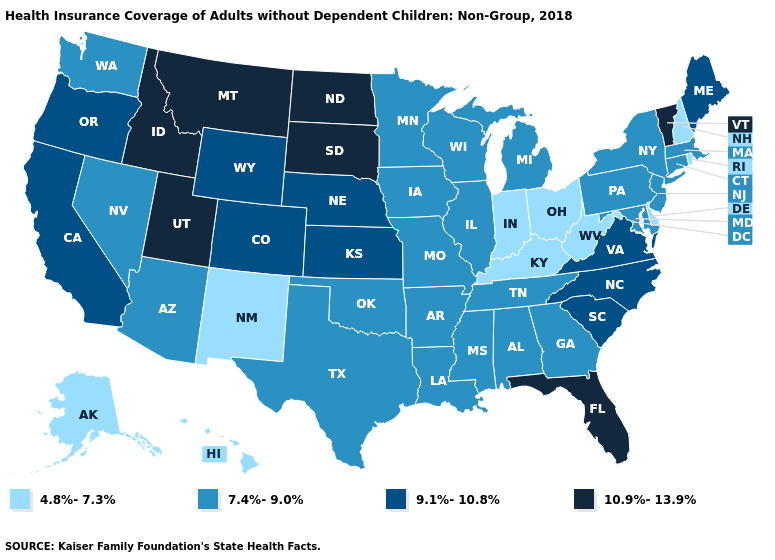What is the value of New Hampshire?
Short answer required. 4.8%-7.3%. Does the first symbol in the legend represent the smallest category?
Short answer required. Yes. What is the value of Louisiana?
Write a very short answer. 7.4%-9.0%. Among the states that border Kansas , does Missouri have the highest value?
Keep it brief. No. Does Florida have the same value as Maryland?
Write a very short answer. No. What is the highest value in states that border New York?
Short answer required. 10.9%-13.9%. Name the states that have a value in the range 9.1%-10.8%?
Short answer required. California, Colorado, Kansas, Maine, Nebraska, North Carolina, Oregon, South Carolina, Virginia, Wyoming. Name the states that have a value in the range 7.4%-9.0%?
Short answer required. Alabama, Arizona, Arkansas, Connecticut, Georgia, Illinois, Iowa, Louisiana, Maryland, Massachusetts, Michigan, Minnesota, Mississippi, Missouri, Nevada, New Jersey, New York, Oklahoma, Pennsylvania, Tennessee, Texas, Washington, Wisconsin. Does New York have the lowest value in the Northeast?
Quick response, please. No. What is the highest value in the USA?
Keep it brief. 10.9%-13.9%. What is the value of Wisconsin?
Write a very short answer. 7.4%-9.0%. Which states have the lowest value in the West?
Keep it brief. Alaska, Hawaii, New Mexico. Does South Dakota have a higher value than Pennsylvania?
Write a very short answer. Yes. Does California have the highest value in the West?
Be succinct. No. Name the states that have a value in the range 10.9%-13.9%?
Be succinct. Florida, Idaho, Montana, North Dakota, South Dakota, Utah, Vermont. 